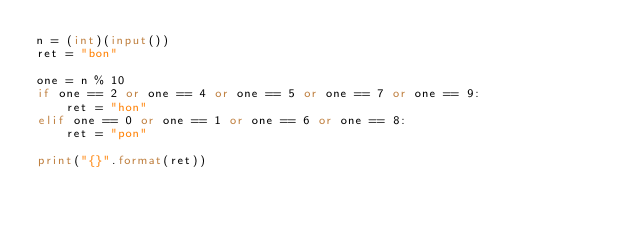Convert code to text. <code><loc_0><loc_0><loc_500><loc_500><_Python_>n = (int)(input())
ret = "bon"

one = n % 10
if one == 2 or one == 4 or one == 5 or one == 7 or one == 9:
    ret = "hon"
elif one == 0 or one == 1 or one == 6 or one == 8:
    ret = "pon"

print("{}".format(ret))</code> 